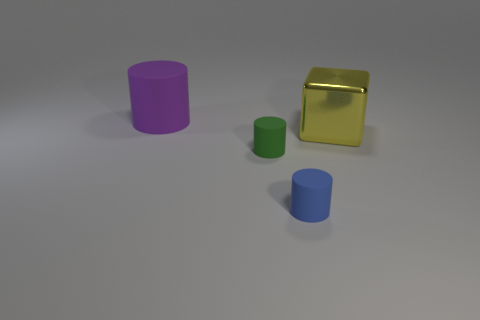There is a blue cylinder that is made of the same material as the big purple object; what size is it?
Your answer should be very brief. Small. What number of large purple objects are the same shape as the blue thing?
Provide a succinct answer. 1. What number of things are matte cylinders to the right of the purple matte cylinder or big metallic blocks that are to the right of the large rubber cylinder?
Your answer should be compact. 3. What number of rubber things are behind the thing in front of the green cylinder?
Your answer should be very brief. 2. There is a matte thing behind the large block; is its shape the same as the small matte thing that is to the left of the tiny blue thing?
Offer a very short reply. Yes. Are there any green things that have the same material as the green cylinder?
Give a very brief answer. No. How many rubber objects are blue things or large purple objects?
Give a very brief answer. 2. There is a big purple matte thing behind the large thing that is in front of the large purple thing; what is its shape?
Provide a short and direct response. Cylinder. Are there fewer small matte cylinders that are left of the large metallic block than yellow metallic things?
Your answer should be compact. No. What shape is the large purple rubber thing?
Your answer should be very brief. Cylinder. 